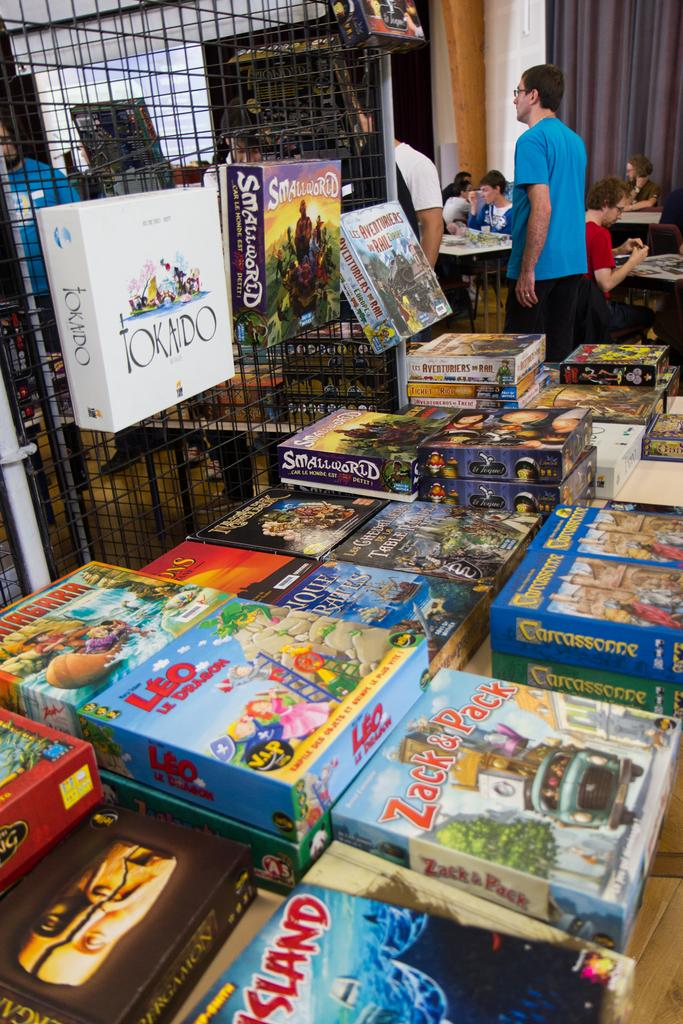<image>
Relay a brief, clear account of the picture shown. A table of board games such as Zack and Pack and Tokado. 